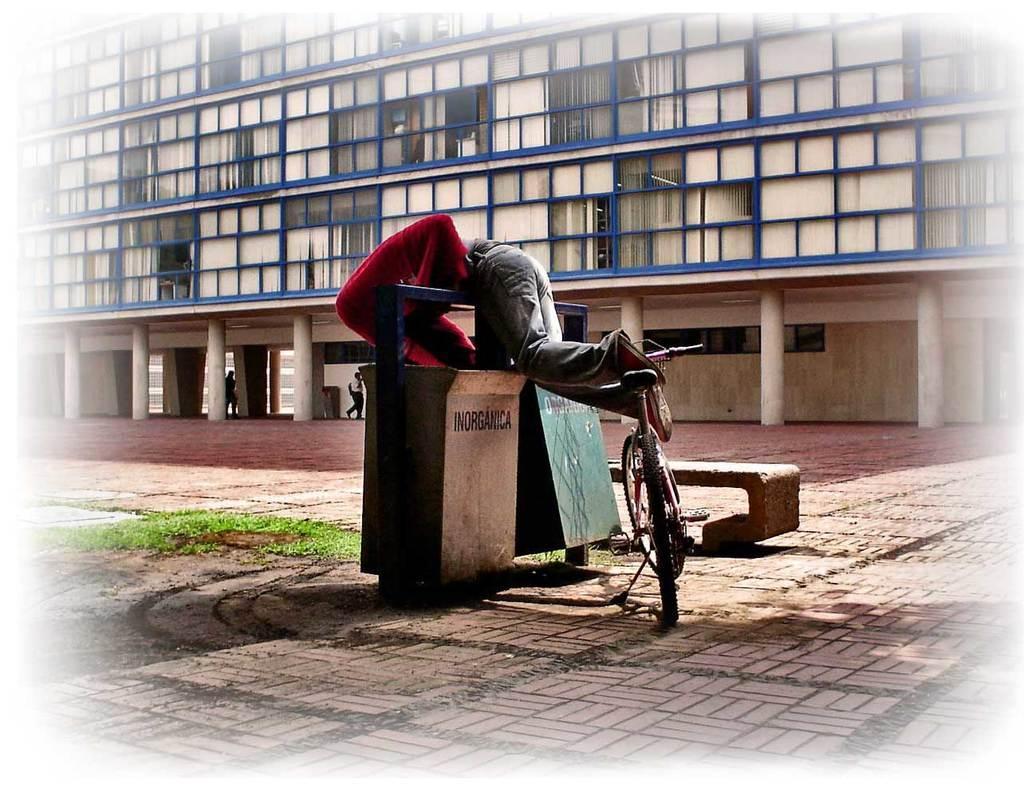Can you describe this image briefly? This picture is clicked outside the city. The man in red t-shirt is on bicycle, is into the garbage bin. Beside that, we see a bench and on background, we see a building with seven pillars and we can even see windows and curtains of that building. 